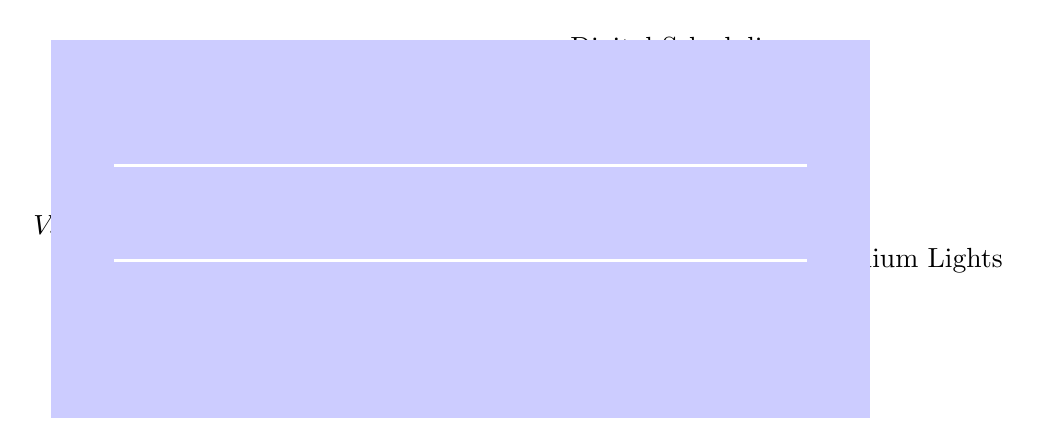What is the input voltage of the circuit? The circuit diagram indicates an input voltage source labeled as \( V_{in} \), which is the source voltage connected at the top of the diagram.
Answer: V_in What type of component is \( P_1 \)? \( P_1 \) is labeled as a potentiometer, which is a variable resistor used for adjusting levels, in this case likely for dimming the lights.
Answer: Potentiometer What is the purpose of the operational amplifier in the circuit? The operational amplifier, typically denoted with a triangle symbol, is used to amplify the signal from the potentiometer, making it suitable for controlling the output to the stadium lights.
Answer: Signal amplification What switches the output to the stadium lights? The output to the stadium lights is switched by the transistor, indicated by \( Q1 \), which acts as a switch controlled by the microcontroller unit (MCU).
Answer: Transistor How many main functional blocks are shown in this circuit? The circuit contains two distinct functional blocks: one for analog dimming (including the voltage source, resistor, potentiometer, and amplifier) and one for digital scheduling (with the MCU).
Answer: Two What is the main function of the microcontroller unit? The microcontroller unit (MCU) handles the scheduling of the lighting system, allowing for programmable on/off timing or brightness control based on pre-defined settings.
Answer: Programmable control What is the output load represented in the circuit? The output load represented in the circuit is the lamp, labeled \( L_1 \), which indicates where the power is ultimately delivered to illuminate the stadium.
Answer: Lamp 